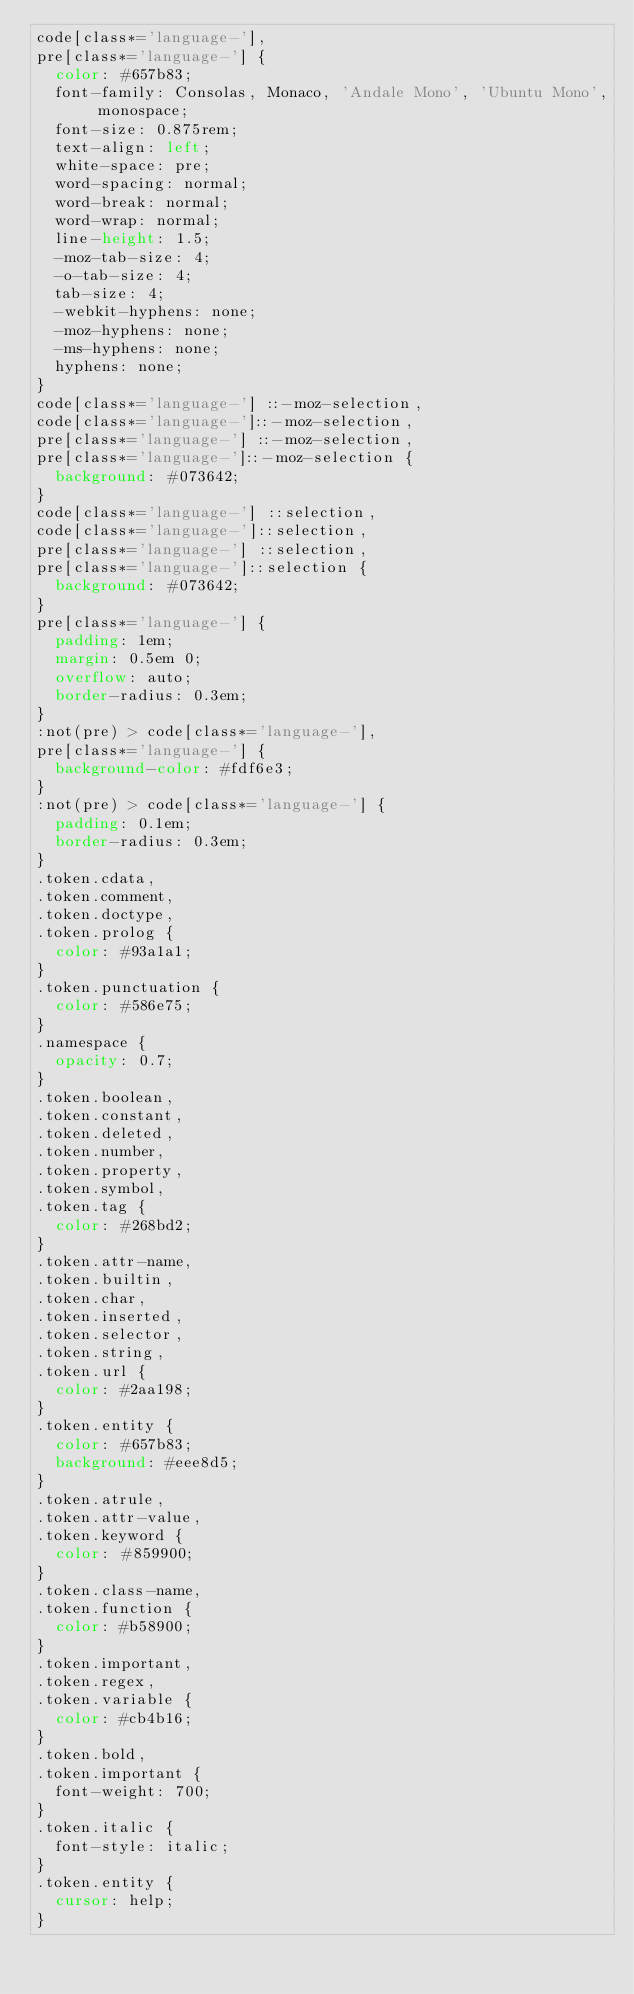<code> <loc_0><loc_0><loc_500><loc_500><_CSS_>code[class*='language-'],
pre[class*='language-'] {
  color: #657b83;
  font-family: Consolas, Monaco, 'Andale Mono', 'Ubuntu Mono', monospace;
  font-size: 0.875rem;
  text-align: left;
  white-space: pre;
  word-spacing: normal;
  word-break: normal;
  word-wrap: normal;
  line-height: 1.5;
  -moz-tab-size: 4;
  -o-tab-size: 4;
  tab-size: 4;
  -webkit-hyphens: none;
  -moz-hyphens: none;
  -ms-hyphens: none;
  hyphens: none;
}
code[class*='language-'] ::-moz-selection,
code[class*='language-']::-moz-selection,
pre[class*='language-'] ::-moz-selection,
pre[class*='language-']::-moz-selection {
  background: #073642;
}
code[class*='language-'] ::selection,
code[class*='language-']::selection,
pre[class*='language-'] ::selection,
pre[class*='language-']::selection {
  background: #073642;
}
pre[class*='language-'] {
  padding: 1em;
  margin: 0.5em 0;
  overflow: auto;
  border-radius: 0.3em;
}
:not(pre) > code[class*='language-'],
pre[class*='language-'] {
  background-color: #fdf6e3;
}
:not(pre) > code[class*='language-'] {
  padding: 0.1em;
  border-radius: 0.3em;
}
.token.cdata,
.token.comment,
.token.doctype,
.token.prolog {
  color: #93a1a1;
}
.token.punctuation {
  color: #586e75;
}
.namespace {
  opacity: 0.7;
}
.token.boolean,
.token.constant,
.token.deleted,
.token.number,
.token.property,
.token.symbol,
.token.tag {
  color: #268bd2;
}
.token.attr-name,
.token.builtin,
.token.char,
.token.inserted,
.token.selector,
.token.string,
.token.url {
  color: #2aa198;
}
.token.entity {
  color: #657b83;
  background: #eee8d5;
}
.token.atrule,
.token.attr-value,
.token.keyword {
  color: #859900;
}
.token.class-name,
.token.function {
  color: #b58900;
}
.token.important,
.token.regex,
.token.variable {
  color: #cb4b16;
}
.token.bold,
.token.important {
  font-weight: 700;
}
.token.italic {
  font-style: italic;
}
.token.entity {
  cursor: help;
}
</code> 